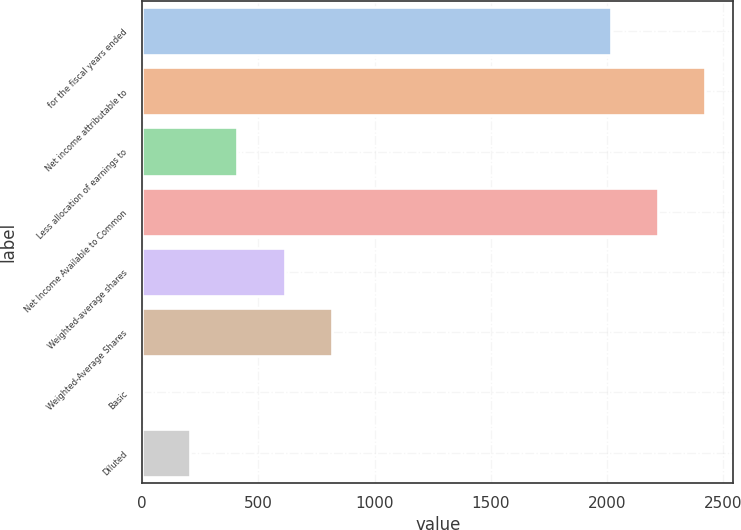Convert chart. <chart><loc_0><loc_0><loc_500><loc_500><bar_chart><fcel>for the fiscal years ended<fcel>Net income attributable to<fcel>Less allocation of earnings to<fcel>Net Income Available to Common<fcel>Weighted-average shares<fcel>Weighted-Average Shares<fcel>Basic<fcel>Diluted<nl><fcel>2015<fcel>2421.4<fcel>409.69<fcel>2218.2<fcel>614.8<fcel>818<fcel>3.29<fcel>206.49<nl></chart> 